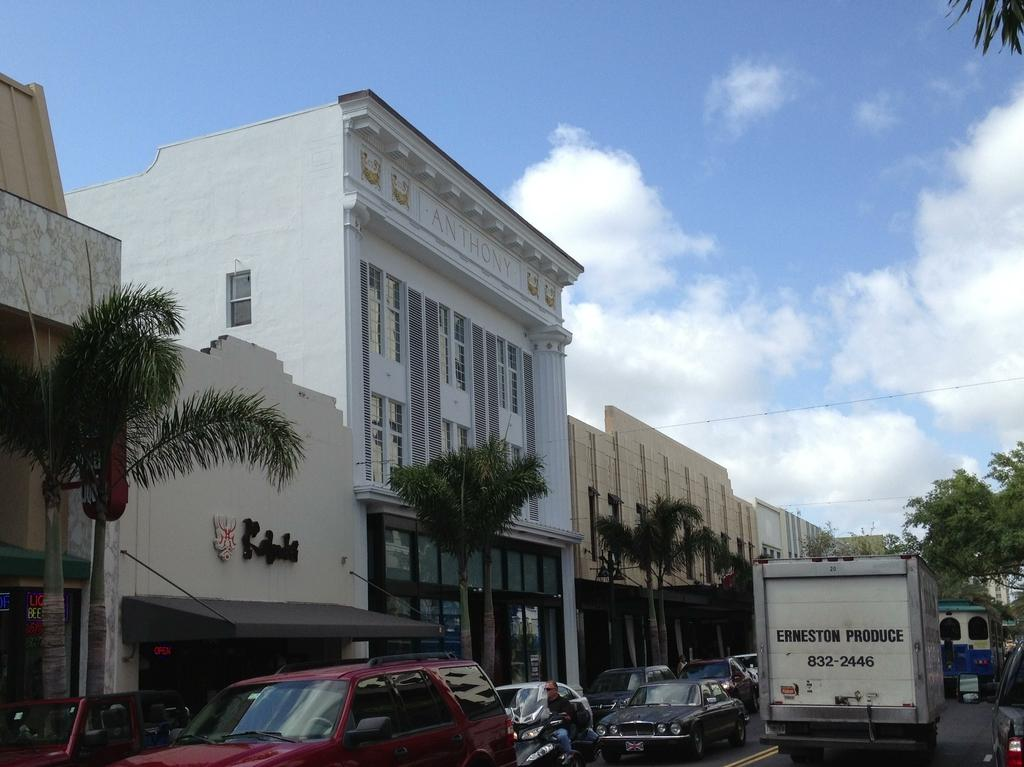What types of structures can be seen in the image? There are buildings in the image. What other natural elements are present in the image? There are trees in the image. What man-made objects can be seen in the image? There are vehicles in the image. What is the surface on which the buildings, trees, and vehicles are situated? The ground is visible in the image. Is there any human presence in the image? Yes, there is a person in the image. What else can be seen in the image that is not directly related to the buildings, trees, vehicles, or person? There are wires in the image. What part of the natural environment is visible in the image? The sky is visible in the image, and clouds are present in the sky. Where is the playground located in the image? There is no playground present in the image. What type of salt is being used to season the trees in the image? There is no salt or seasoning present in the image, as trees do not require seasoning. 